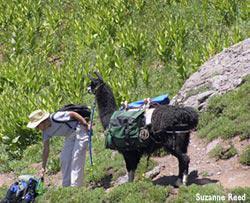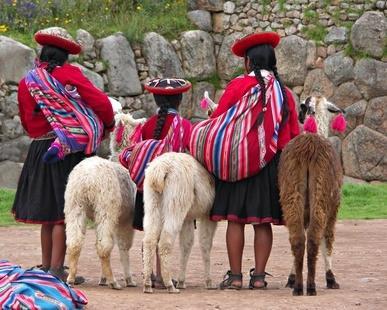The first image is the image on the left, the second image is the image on the right. For the images shown, is this caption "The right image shows multiple people standing near multiple llamas wearing packs and facing mountain peaks." true? Answer yes or no. No. The first image is the image on the left, the second image is the image on the right. Assess this claim about the two images: "The llamas in the right image are carrying packs.". Correct or not? Answer yes or no. No. 